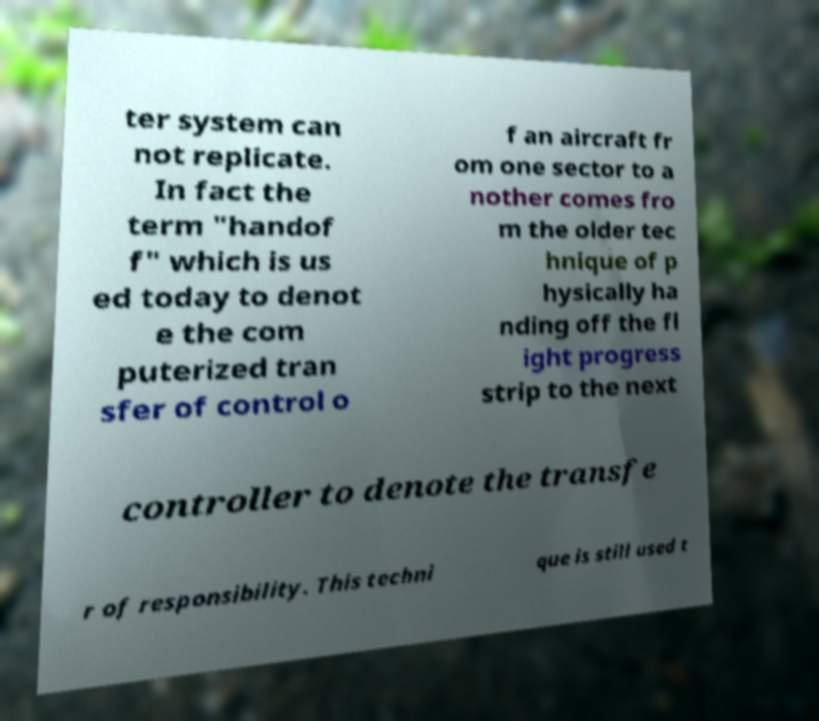For documentation purposes, I need the text within this image transcribed. Could you provide that? ter system can not replicate. In fact the term "handof f" which is us ed today to denot e the com puterized tran sfer of control o f an aircraft fr om one sector to a nother comes fro m the older tec hnique of p hysically ha nding off the fl ight progress strip to the next controller to denote the transfe r of responsibility. This techni que is still used t 